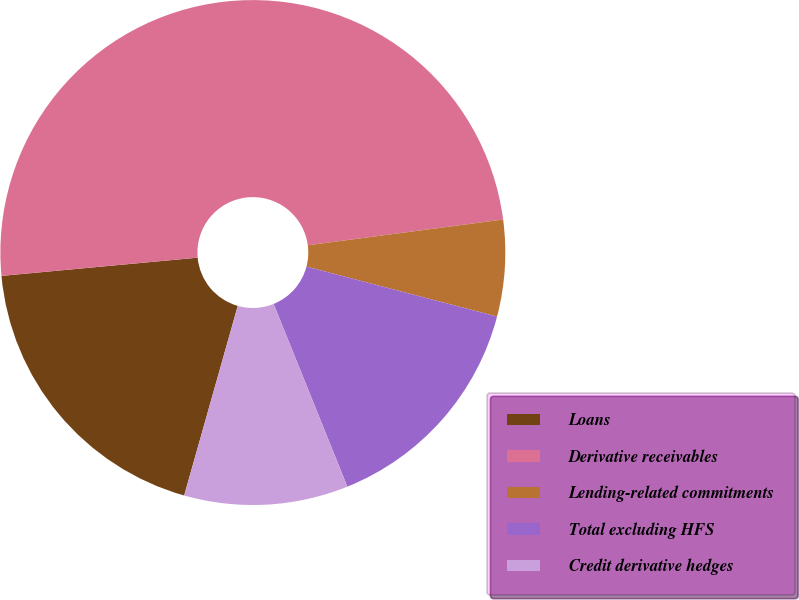<chart> <loc_0><loc_0><loc_500><loc_500><pie_chart><fcel>Loans<fcel>Derivative receivables<fcel>Lending-related commitments<fcel>Total excluding HFS<fcel>Credit derivative hedges<nl><fcel>19.14%<fcel>49.38%<fcel>6.17%<fcel>14.81%<fcel>10.49%<nl></chart> 